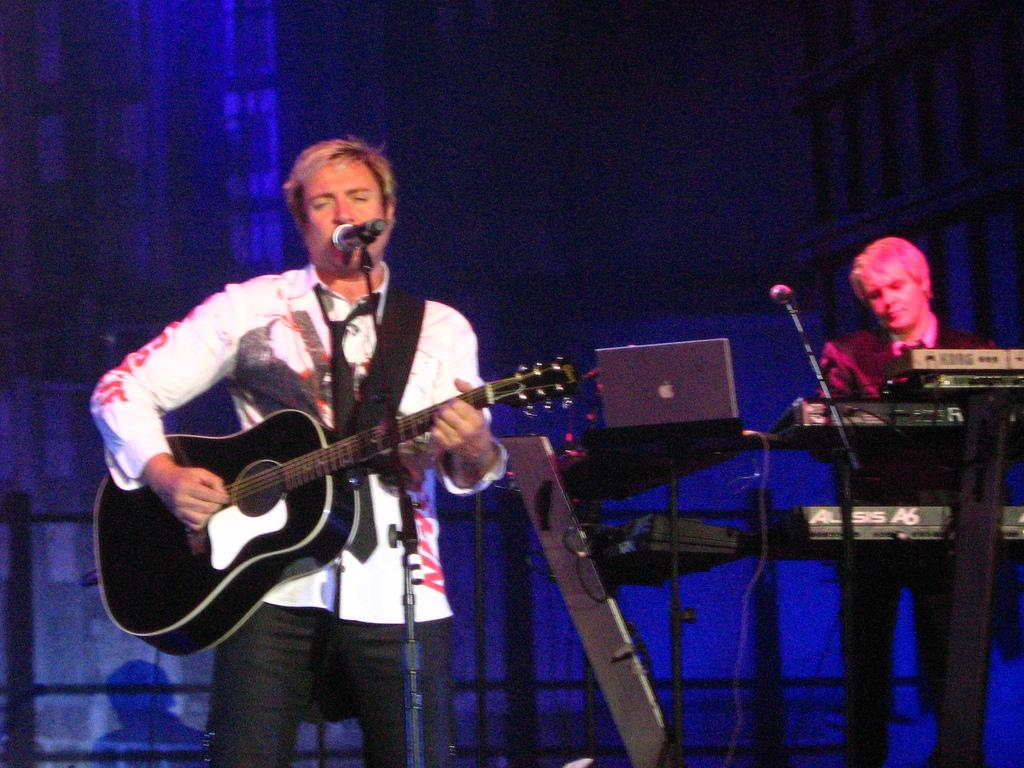What are the two men in the image doing? There is a man playing guitar and another man playing piano in the image. What might they be using the microphone for? They might be using the microphone for amplifying their music or for singing. Can you describe the instruments they are playing? One man is playing a guitar, and the other is playing a piano. How many cows can be seen grazing in the background of the image? There are no cows present in the image; it features two men playing musical instruments with a microphone in front of them. 